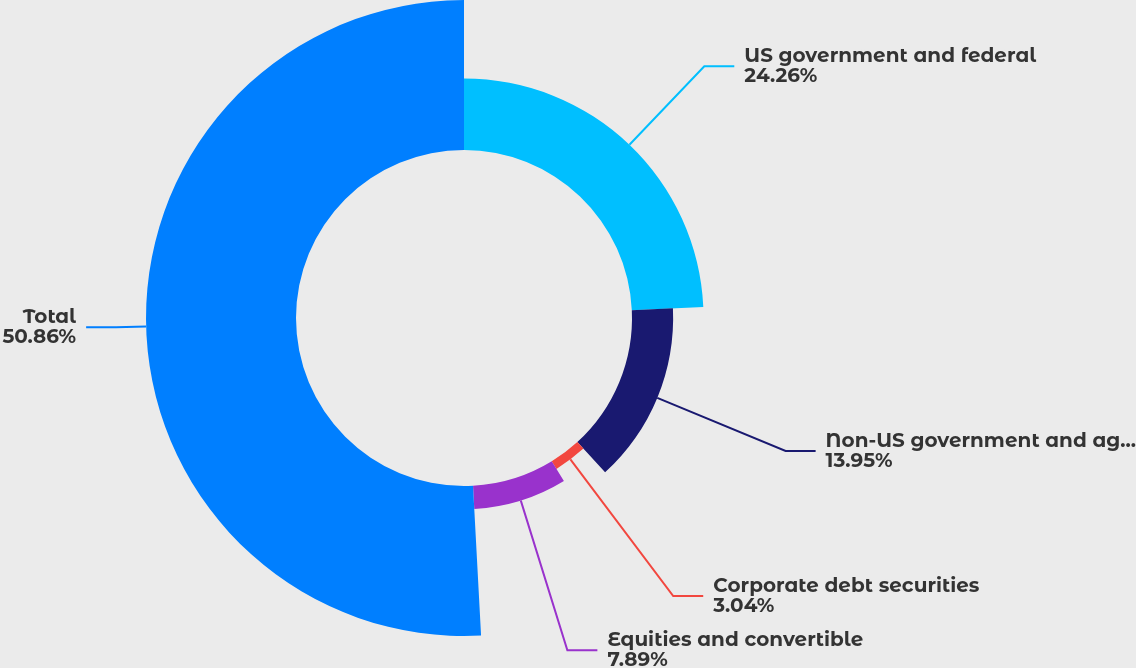<chart> <loc_0><loc_0><loc_500><loc_500><pie_chart><fcel>US government and federal<fcel>Non-US government and agency<fcel>Corporate debt securities<fcel>Equities and convertible<fcel>Total<nl><fcel>24.26%<fcel>13.95%<fcel>3.04%<fcel>7.89%<fcel>50.85%<nl></chart> 